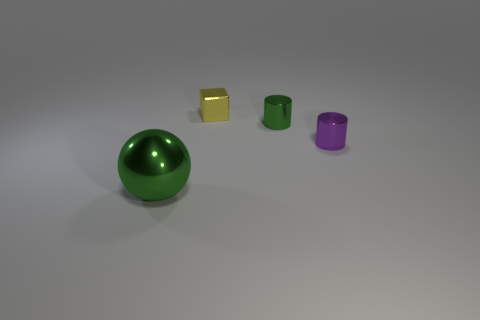Subtract all green cylinders. How many cylinders are left? 1 Add 4 shiny spheres. How many objects exist? 8 Subtract all cubes. How many objects are left? 3 Add 3 purple objects. How many purple objects are left? 4 Add 2 yellow blocks. How many yellow blocks exist? 3 Subtract 0 gray cylinders. How many objects are left? 4 Subtract all big brown matte cylinders. Subtract all small yellow shiny blocks. How many objects are left? 3 